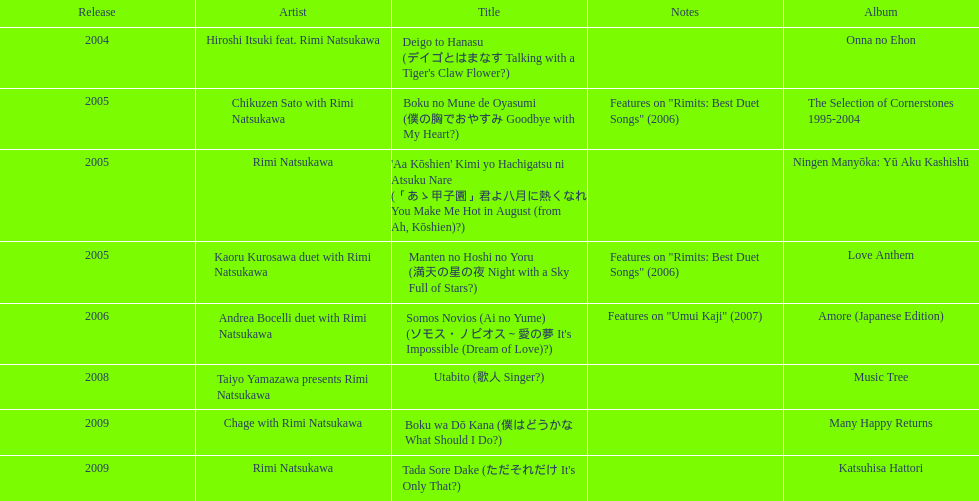Which track featured this artist post-utabito? Boku wa Dō Kana. 